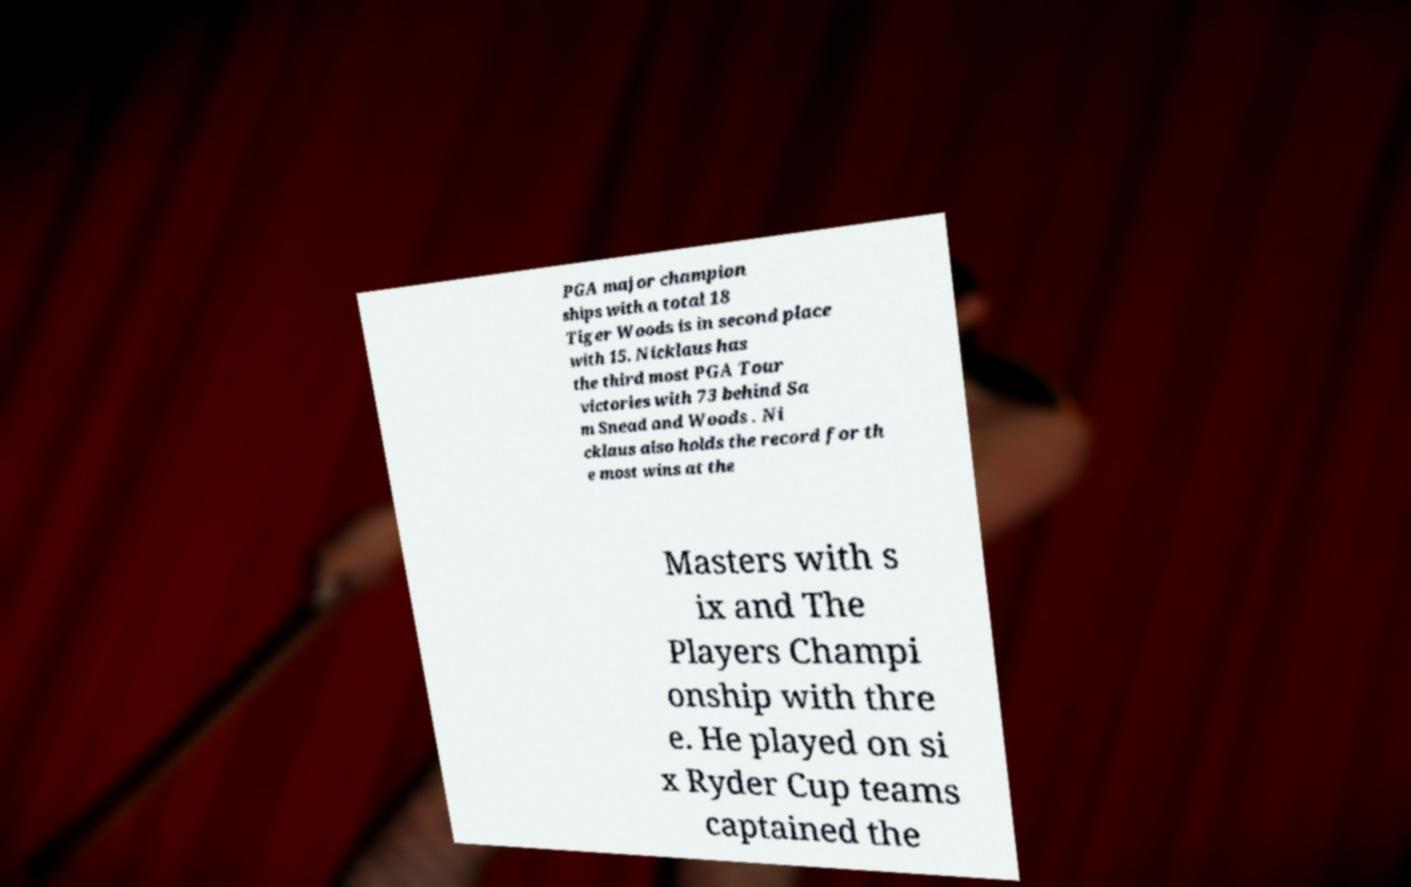Could you extract and type out the text from this image? PGA major champion ships with a total 18 Tiger Woods is in second place with 15. Nicklaus has the third most PGA Tour victories with 73 behind Sa m Snead and Woods . Ni cklaus also holds the record for th e most wins at the Masters with s ix and The Players Champi onship with thre e. He played on si x Ryder Cup teams captained the 